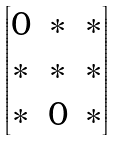Convert formula to latex. <formula><loc_0><loc_0><loc_500><loc_500>\begin{bmatrix} 0 & * & * \\ * & * & * \\ * & 0 & * \end{bmatrix}</formula> 